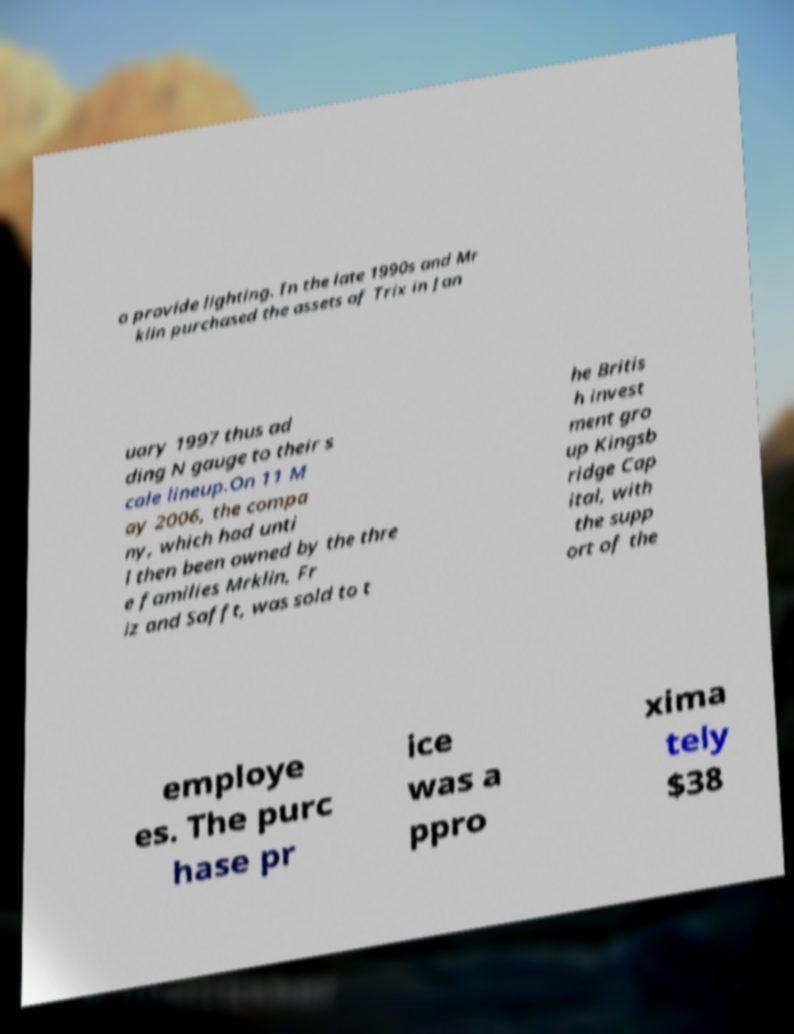What messages or text are displayed in this image? I need them in a readable, typed format. o provide lighting. In the late 1990s and Mr klin purchased the assets of Trix in Jan uary 1997 thus ad ding N gauge to their s cale lineup.On 11 M ay 2006, the compa ny, which had unti l then been owned by the thre e families Mrklin, Fr iz and Safft, was sold to t he Britis h invest ment gro up Kingsb ridge Cap ital, with the supp ort of the employe es. The purc hase pr ice was a ppro xima tely $38 